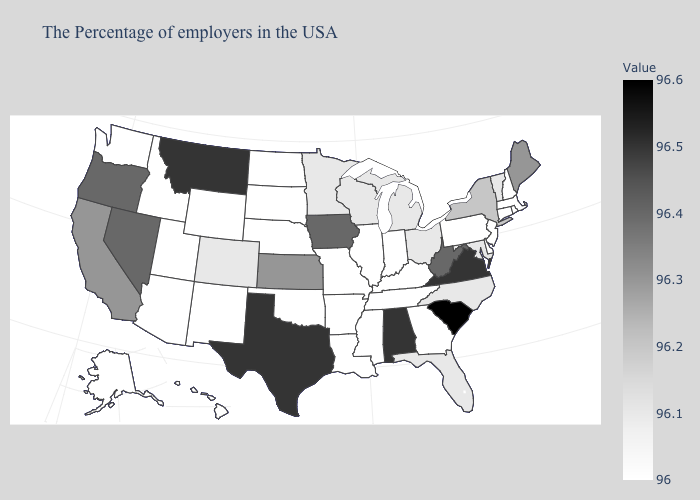Among the states that border North Dakota , which have the lowest value?
Keep it brief. South Dakota. Among the states that border Michigan , which have the lowest value?
Keep it brief. Indiana. Which states have the lowest value in the South?
Give a very brief answer. Delaware, Georgia, Kentucky, Tennessee, Mississippi, Louisiana, Arkansas, Oklahoma. Which states have the lowest value in the USA?
Quick response, please. Massachusetts, Rhode Island, New Hampshire, Connecticut, New Jersey, Delaware, Pennsylvania, Georgia, Kentucky, Indiana, Tennessee, Illinois, Mississippi, Louisiana, Missouri, Arkansas, Nebraska, Oklahoma, South Dakota, North Dakota, Wyoming, New Mexico, Utah, Arizona, Idaho, Washington, Alaska, Hawaii. Which states have the lowest value in the South?
Quick response, please. Delaware, Georgia, Kentucky, Tennessee, Mississippi, Louisiana, Arkansas, Oklahoma. Among the states that border Connecticut , which have the highest value?
Keep it brief. New York. Among the states that border Oklahoma , does Missouri have the highest value?
Short answer required. No. Does South Carolina have the highest value in the USA?
Give a very brief answer. Yes. Does Wisconsin have a lower value than Arkansas?
Be succinct. No. Which states have the lowest value in the South?
Quick response, please. Delaware, Georgia, Kentucky, Tennessee, Mississippi, Louisiana, Arkansas, Oklahoma. 